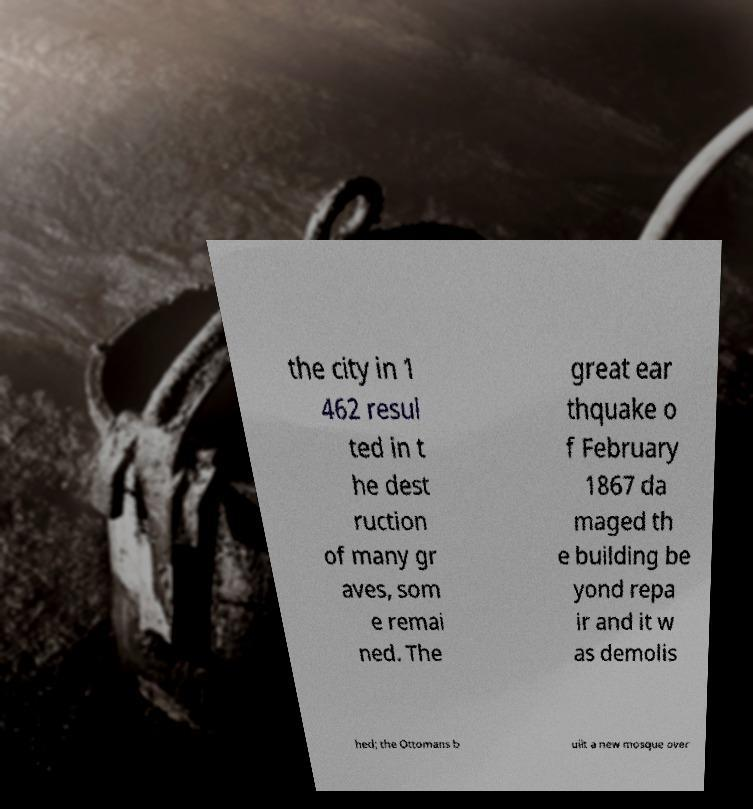Can you accurately transcribe the text from the provided image for me? the city in 1 462 resul ted in t he dest ruction of many gr aves, som e remai ned. The great ear thquake o f February 1867 da maged th e building be yond repa ir and it w as demolis hed; the Ottomans b uilt a new mosque over 